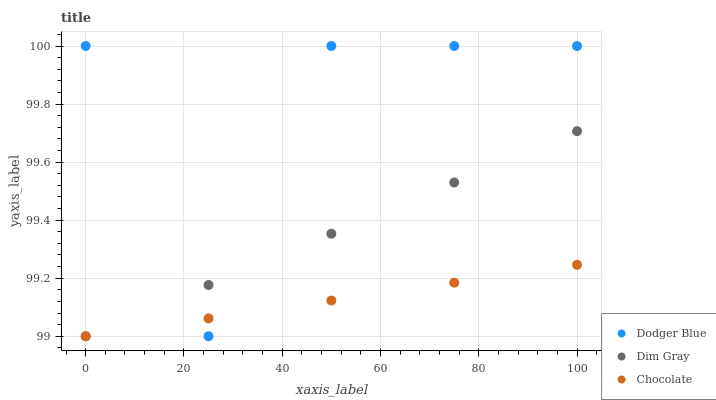Does Chocolate have the minimum area under the curve?
Answer yes or no. Yes. Does Dodger Blue have the maximum area under the curve?
Answer yes or no. Yes. Does Dodger Blue have the minimum area under the curve?
Answer yes or no. No. Does Chocolate have the maximum area under the curve?
Answer yes or no. No. Is Chocolate the smoothest?
Answer yes or no. Yes. Is Dodger Blue the roughest?
Answer yes or no. Yes. Is Dodger Blue the smoothest?
Answer yes or no. No. Is Chocolate the roughest?
Answer yes or no. No. Does Dim Gray have the lowest value?
Answer yes or no. Yes. Does Dodger Blue have the lowest value?
Answer yes or no. No. Does Dodger Blue have the highest value?
Answer yes or no. Yes. Does Chocolate have the highest value?
Answer yes or no. No. Does Dodger Blue intersect Dim Gray?
Answer yes or no. Yes. Is Dodger Blue less than Dim Gray?
Answer yes or no. No. Is Dodger Blue greater than Dim Gray?
Answer yes or no. No. 